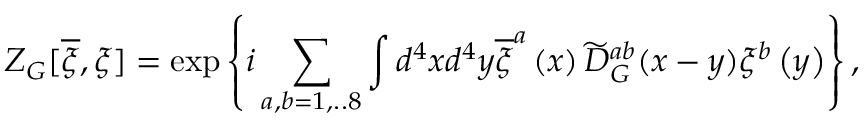<formula> <loc_0><loc_0><loc_500><loc_500>Z _ { G } [ \overline { \xi } , \xi ] = \exp \left \{ i \sum _ { a , b = 1 , . . 8 } \int d ^ { 4 } x d ^ { 4 } y \overline { \xi } ^ { a } \left ( x \right ) \widetilde { D } _ { G } ^ { a b } ( x - y ) \xi ^ { b } \left ( y \right ) \right \} ,</formula> 